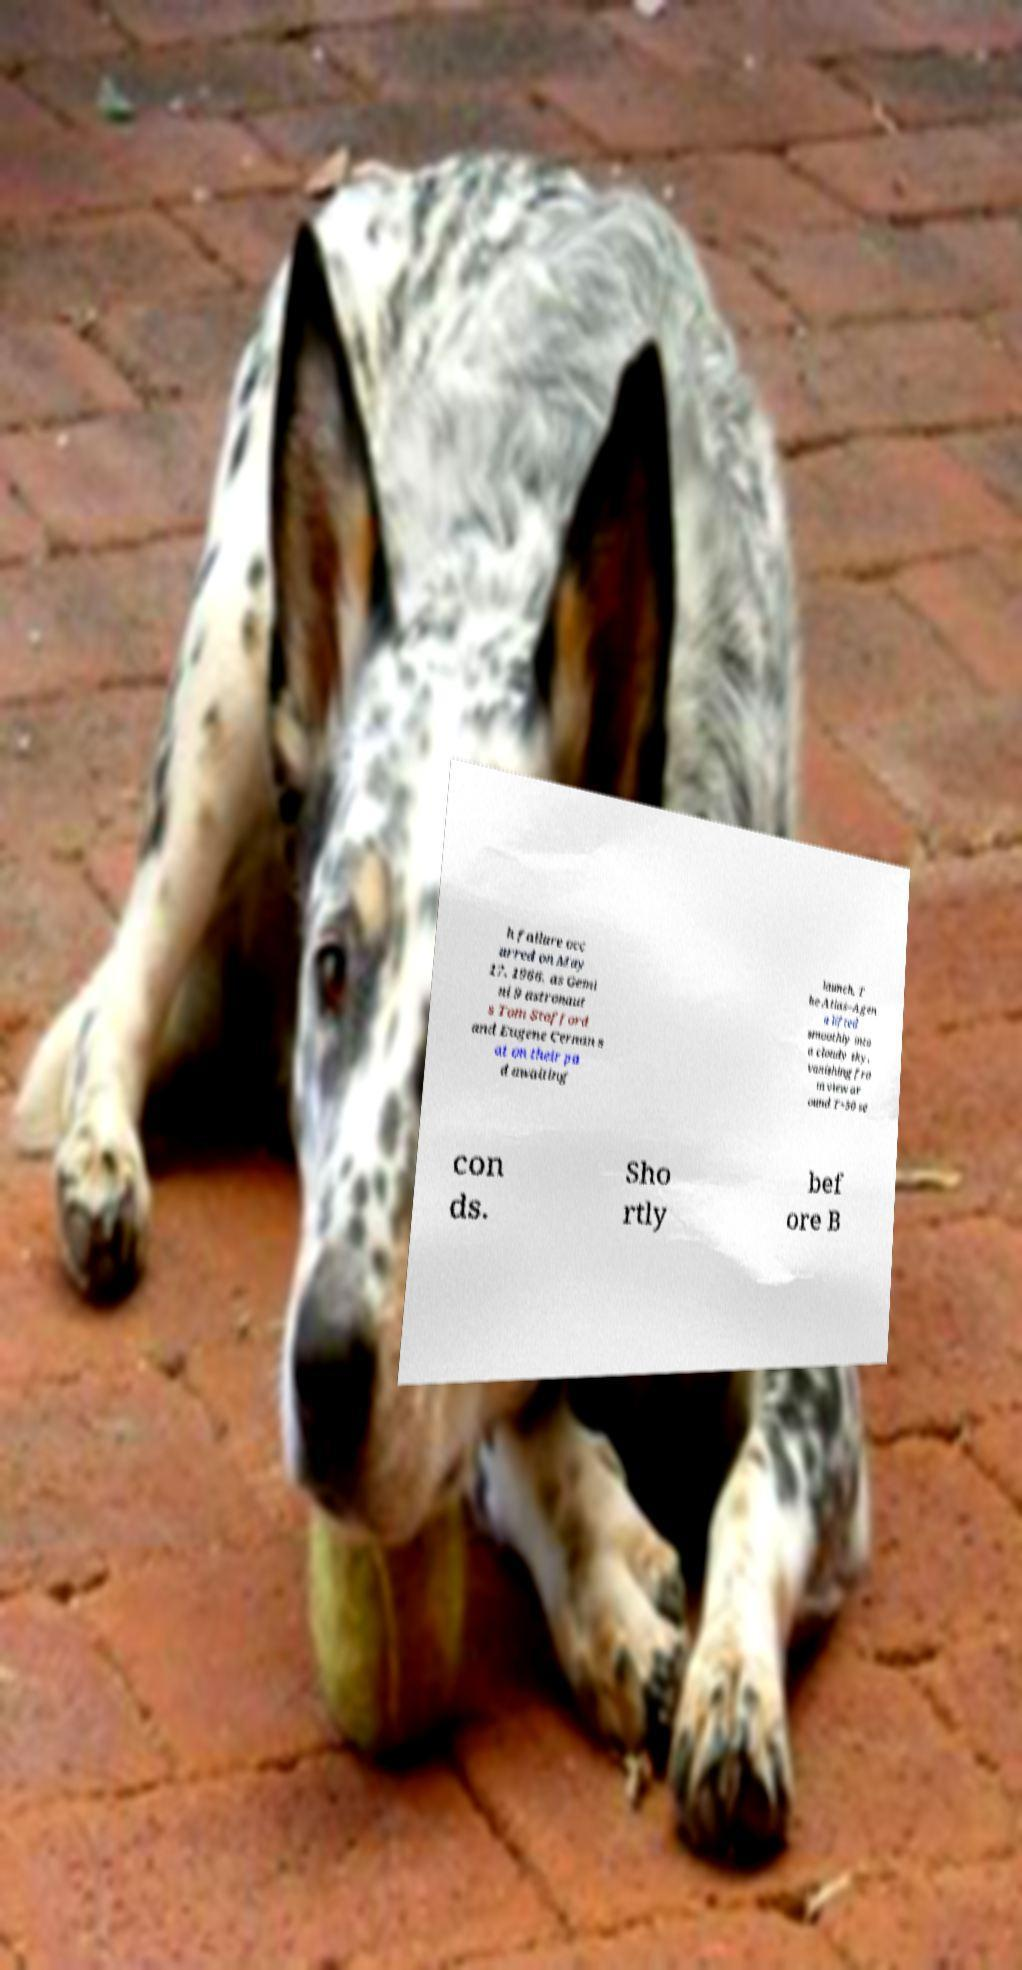Please read and relay the text visible in this image. What does it say? h failure occ urred on May 17, 1966, as Gemi ni 9 astronaut s Tom Stafford and Eugene Cernan s at on their pa d awaiting launch. T he Atlas–Agen a lifted smoothly into a cloudy sky, vanishing fro m view ar ound T+50 se con ds. Sho rtly bef ore B 